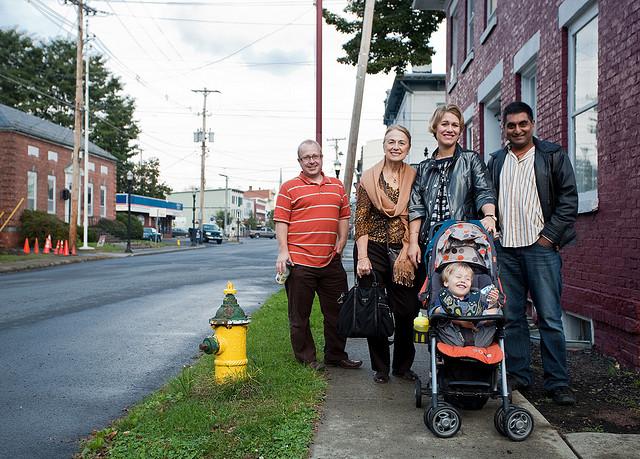How many women are in the picture?
Give a very brief answer. 2. Is the child in a stroller?
Quick response, please. Yes. Is this urban or country setting?
Short answer required. Urban. 